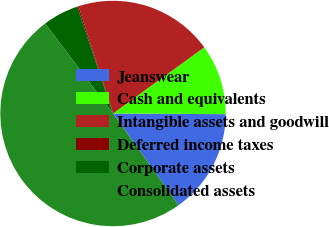<chart> <loc_0><loc_0><loc_500><loc_500><pie_chart><fcel>Jeanswear<fcel>Cash and equivalents<fcel>Intangible assets and goodwill<fcel>Deferred income taxes<fcel>Corporate assets<fcel>Consolidated assets<nl><fcel>15.02%<fcel>10.08%<fcel>19.96%<fcel>0.2%<fcel>5.14%<fcel>49.6%<nl></chart> 